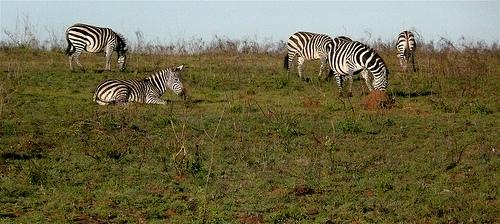Describe the appearance of the zebras in the image. The zebras have stripes that curve in toward the belly, with some facing right and one having a big belly. Provide a brief description of the scene depicted in the image. A group of zebras is eating grass in a field filled with brown and green grass, dead sticks, and shrubs, while one zebra lays down in the grass. Is there any object interaction in the image? If so, describe one instance. Yes, a zebra is interacting with the environment by eating some grass. Point out the unique feature of a particular zebra mentioned in the image. One zebra has its head behind a dirt pile. What is the primary action taking place in this image? Several zebras are eating grass in a large pasture. Identify the object in the image that is not a part of the natural environment. There is a brown dirt pile in the grassy field. What is the sentiment conveyed by the image? The image conveys a peaceful and natural sentiment, as several zebras are calmly eating grass in a spacious field. What is the total number of zebras mentioned in the image details? The image details mention five zebras in a field, four zebras facing right, and one zebra laying down. How many zebras are eating grass and how many are laying down? There are multiple zebras eating grass and one zebra laying down in the field. List all the different types of vegetation described in the image. Grass, small shrubs, dead sticks, tall dried-out twigs, and brown shrub. Is the zebra standing on its hind legs at position X:107 Y:57? There is a zebra at position X:107 Y:57, but it is laying down in the grass, not standing on its hind legs. Can you find the purple bush in the grass at position X:344 Y:86? There is a brown shrub in the grass at position X:344 Y:86, but there is no purple bush mentioned in the image information. Do you see the zebra with sunglasses at position X:62 Y:14? No, it's not mentioned in the image. Can you find a lake filled with water in the image at position X:61 Y:109? There is a large pasture of grass at position X:61 Y:109, but there is no lake filled with water mentioned in the image information. Is there a bird sitting on the sticks at position X:125 Y:117? There are several sticks in front at position X:125 Y:117, but there is no mention of a bird sitting on them in the image information. Is there a zebra at position X:67 Y:20 with pink and blue stripes? There is a zebra with a big belly at position X:67 Y:20, but it has regular white and black stripes, not pink and blue. 